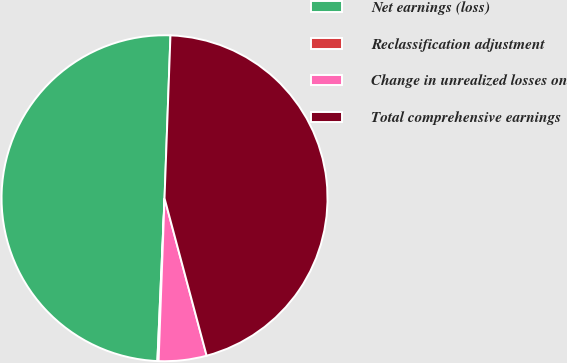Convert chart. <chart><loc_0><loc_0><loc_500><loc_500><pie_chart><fcel>Net earnings (loss)<fcel>Reclassification adjustment<fcel>Change in unrealized losses on<fcel>Total comprehensive earnings<nl><fcel>49.88%<fcel>0.12%<fcel>4.74%<fcel>45.26%<nl></chart> 